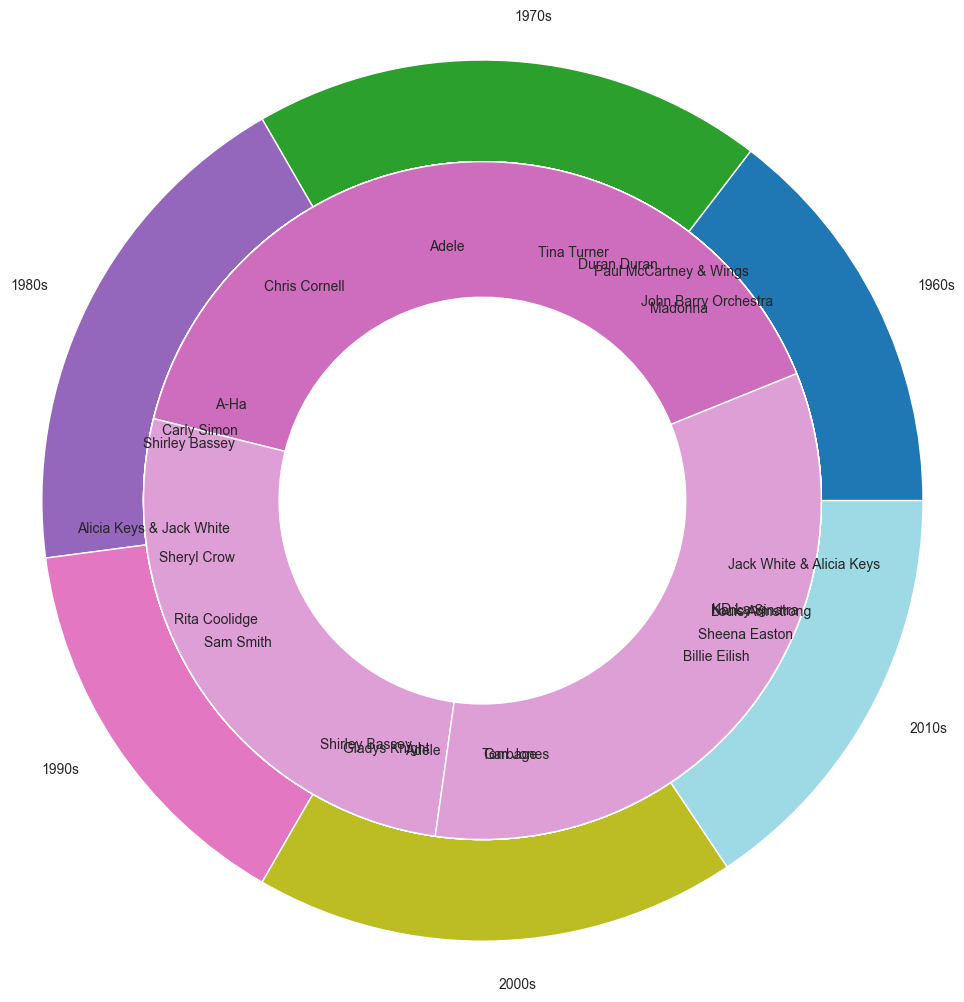Which artist was the most popular in the 1960s? The inner pie chart for the 1960s shows different slices for John Barry Orchestra, Shirley Bassey, Tom Jones, and Nancy Sinatra. The size of Shirley Bassey's slice is the largest, indicating 25% popularity.
Answer: Shirley Bassey Which decade had the highest total popularity? The outer pie chart represents the total popularity of James Bond themes per decade. The 2010s have the largest slice, indicating the highest total popularity.
Answer: 2010s How did the popularity of Adele in the 2010s compare to her popularity in the 2000s? The inner pie chart shows Adele with a 30% slice in the 2010s and 25% slice in the 2000s. She was more popular in the 2010s.
Answer: More popular in the 2010s What is the combined popularity of Shirley Bassey across all decades? Shirley Bassey appears in the 1960s and 1970s. Her popularity is 25% in the 1960s and 25% in the 1970s. Summing these values: 25 + 25 = 50.
Answer: 50 Which decade had the most number of different artists contributing to James Bond themes? Counting the number of artist segments in each inner pie chart, the 1980s have five: Duran Duran, A-Ha, Rita Coolidge, Gladys Knight, Sheena Easton.
Answer: 1980s How does the popularity of Paul McCartney & Wings in the 1970s compare to that of Sam Smith in the 2010s? Paul McCartney & Wings have a 30% slice in the 1970s and Sam Smith has a 20% slice in the 2010s. Paul McCartney & Wings were more popular.
Answer: Paul McCartney & Wings were more popular Which artist has the smallest slice in the 1990s? The inner pie chart for the 1990s shows segments for Tina Turner, Sheryl Crow, Garbage, and KD Lang. Garbage has the smallest slice at 10%.
Answer: Garbage What percentage of total popularity do the artists in the 2000s contribute? Sum the popularity of artists in the 2000s: Madonna (15), Chris Cornell (20), Alicia Keys & Jack White (10), Adele (25), Jack White & Alicia Keys (15). Total: 15 + 20 + 10 + 25 + 15 = 85. To get the percentage out of the total, sum all popularity values across all decades first.
Answer: 85/340 or approximately 25% 